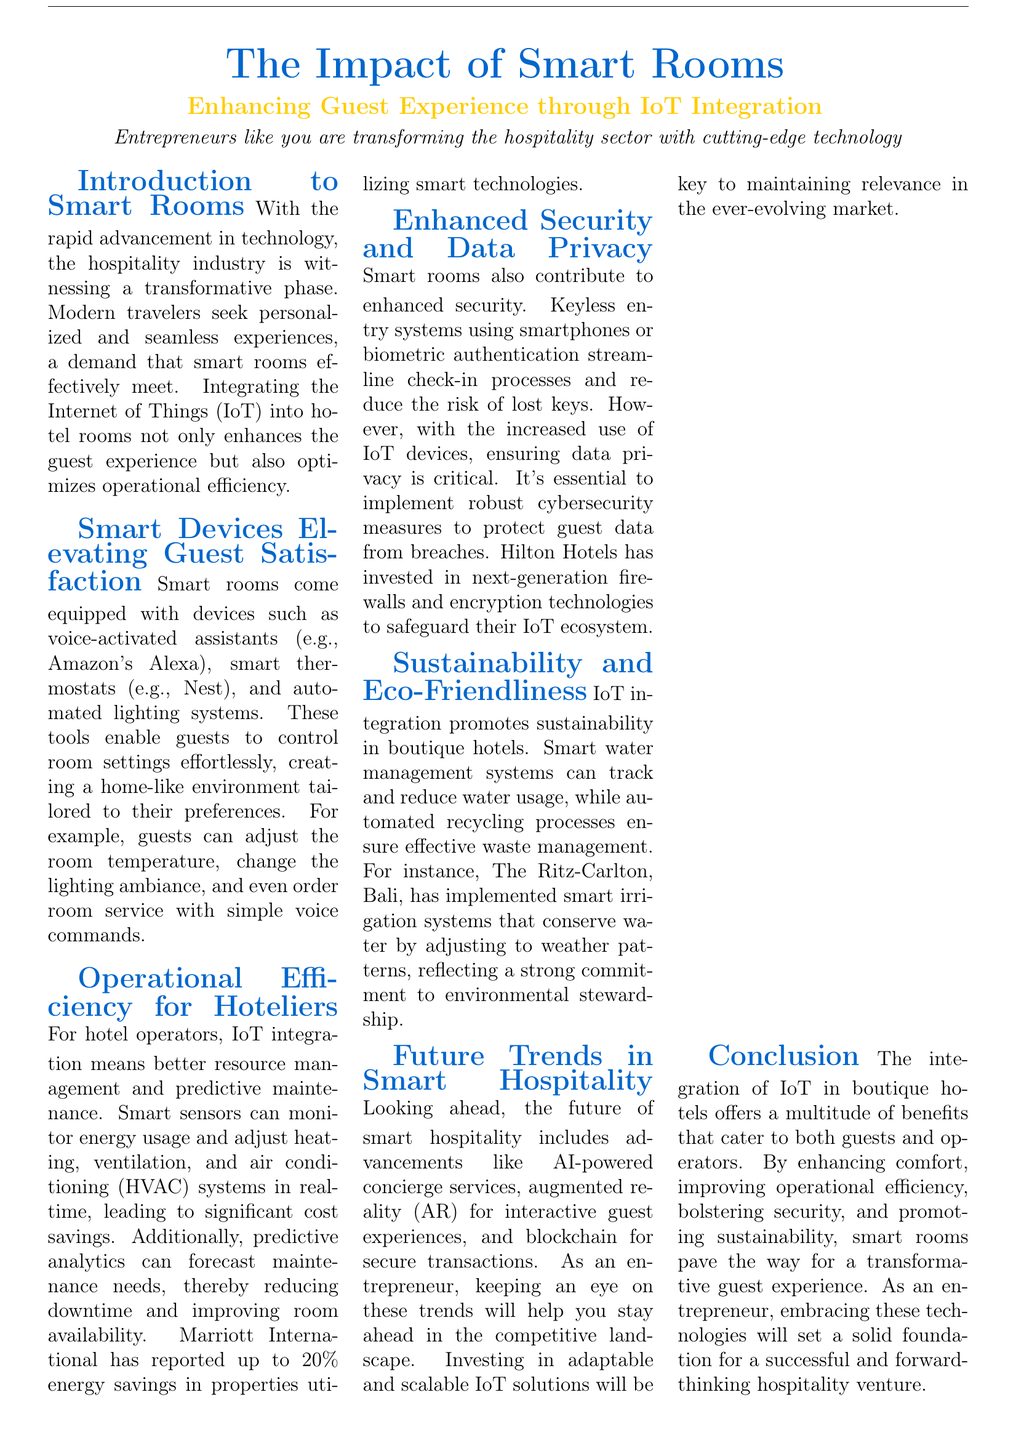What is the main focus of the document? The document discusses the impact of IoT integration in enhancing guest experience in boutique hotels.
Answer: Impact of Smart Rooms Which company reported a 20% energy savings due to smart technologies? The document mentions that Marriott International has reported significant energy savings through the use of smart technologies.
Answer: Marriott International What type of devices are suggested for controlling room settings? The document lists voice-activated assistants, smart thermostats, and automated lighting systems as devices that enhance guest comfort in smart rooms.
Answer: Voice-Activated Assistants (Amazon Alexa, Google Home) What key aspect of smart rooms addresses guest security? The document highlights keyless entry systems as a feature that improves security and streamlines the check-in process for guests.
Answer: Keyless entry systems Who is the CEO of Hilton Hotels? The document quotes Christopher Nassetta, the CEO of Hilton Hotels, discussing the company's investment in smart technology.
Answer: Christopher Nassetta What are the future trends mentioned in the document regarding smart hospitality? The document notes advancements such as AI-powered concierge services, augmented reality, and blockchain as upcoming trends in smart hospitality.
Answer: AI-powered concierge services What does the term "predictive maintenance" refer to in the context of the document? The document describes predictive maintenance as a feature that helps hotel operators forecast maintenance needs, reducing downtime by using IoT sensors.
Answer: Predictive maintenance sensors Which hotel implemented smart irrigation systems for sustainability? The document mentions that The Ritz-Carlton, Bali, has adopted smart irrigation systems to enhance environmental sustainability.
Answer: The Ritz-Carlton, Bali What technology is emphasized for enhancing operational efficiency? The document emphasizes the use of smart sensors for monitoring energy usage and managing HVAC systems in real-time.
Answer: Smart sensors 